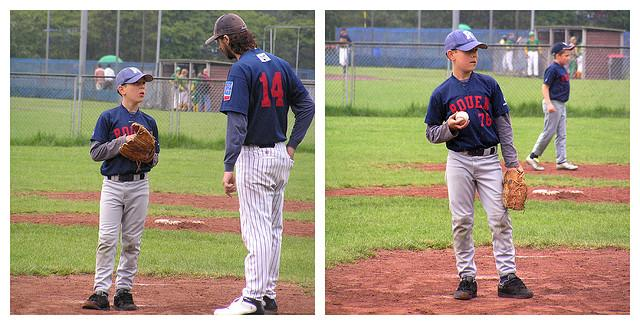What color is the text for this jersey of the boy playing baseball? red 